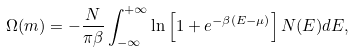<formula> <loc_0><loc_0><loc_500><loc_500>\Omega ( m ) = - \frac { N } { \pi \beta } \int _ { - \infty } ^ { + \infty } \ln \left [ 1 + e ^ { - \beta ( E - \mu ) } \right ] N ( E ) d E ,</formula> 